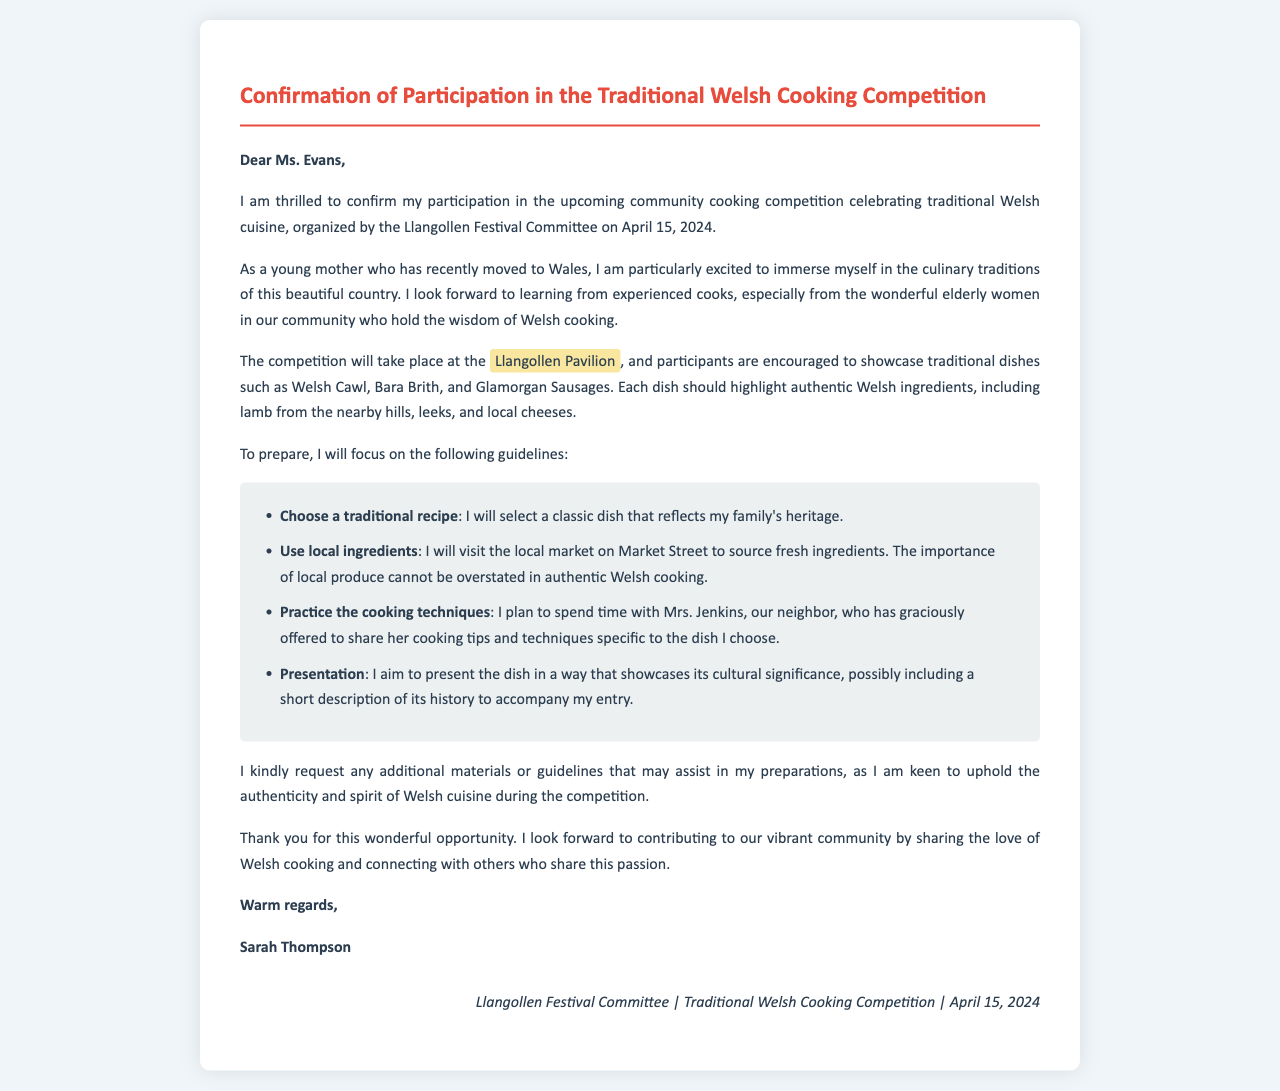What is the date of the cooking competition? The document states the cooking competition will take place on April 15, 2024.
Answer: April 15, 2024 Where will the competition be held? The letter mentions that the competition will take place at the Llangollen Pavilion.
Answer: Llangollen Pavilion Who is the sender of the letter? The letter is signed by Sarah Thompson, indicating her as the sender.
Answer: Sarah Thompson What traditional dish is mentioned first in the document? The letter lists Welsh Cawl as the first traditional dish in the cooking competition.
Answer: Welsh Cawl What is one key guideline for participants? A guideline provided in the letter emphasizes using local ingredients for the dishes.
Answer: Use local ingredients Who has offered to share cooking tips with the sender? The document mentions that Mrs. Jenkins has offered to share her cooking tips and techniques.
Answer: Mrs. Jenkins What is the purpose of the competition? The purpose of the competition is to celebrate traditional Welsh cuisine.
Answer: Celebrate traditional Welsh cuisine What is the importance of local produce in the competition? The document highlights that the importance of local produce cannot be overstated in authentic Welsh cooking.
Answer: Cannot be overstated 